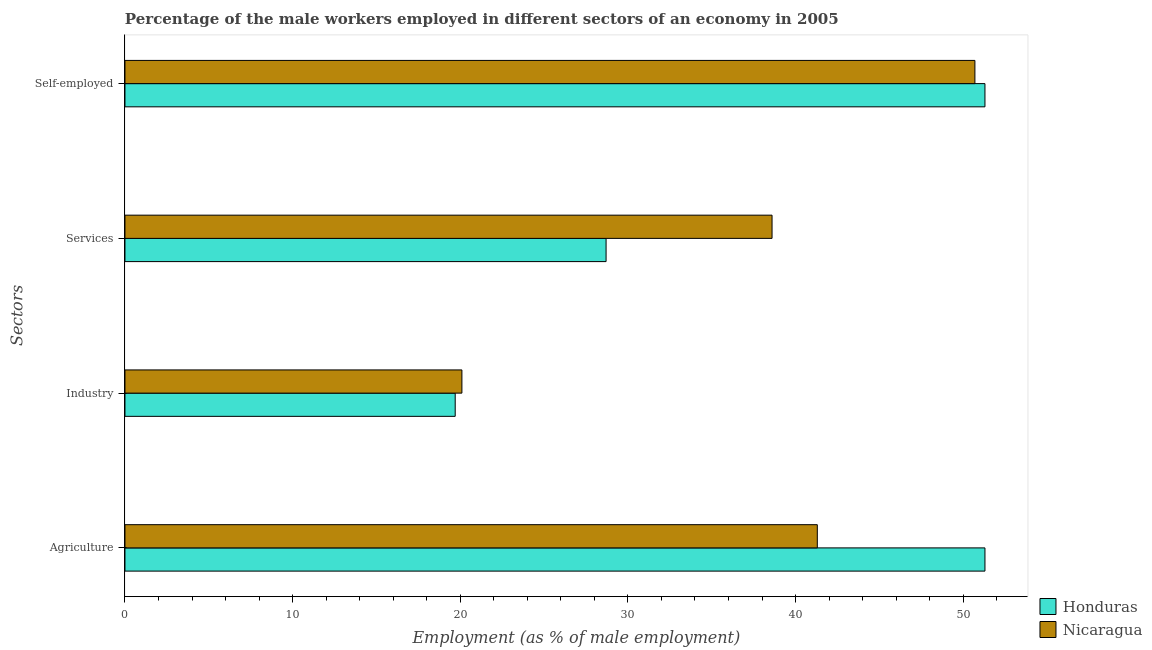How many groups of bars are there?
Make the answer very short. 4. Are the number of bars per tick equal to the number of legend labels?
Ensure brevity in your answer.  Yes. How many bars are there on the 2nd tick from the bottom?
Provide a succinct answer. 2. What is the label of the 3rd group of bars from the top?
Keep it short and to the point. Industry. What is the percentage of male workers in agriculture in Nicaragua?
Your response must be concise. 41.3. Across all countries, what is the maximum percentage of male workers in agriculture?
Ensure brevity in your answer.  51.3. Across all countries, what is the minimum percentage of self employed male workers?
Your answer should be compact. 50.7. In which country was the percentage of male workers in agriculture maximum?
Provide a succinct answer. Honduras. In which country was the percentage of male workers in agriculture minimum?
Ensure brevity in your answer.  Nicaragua. What is the total percentage of male workers in industry in the graph?
Your answer should be very brief. 39.8. What is the difference between the percentage of self employed male workers in Nicaragua and that in Honduras?
Provide a short and direct response. -0.6. What is the difference between the percentage of male workers in industry in Nicaragua and the percentage of self employed male workers in Honduras?
Your response must be concise. -31.2. What is the average percentage of male workers in agriculture per country?
Your answer should be very brief. 46.3. What is the difference between the percentage of male workers in services and percentage of self employed male workers in Nicaragua?
Your answer should be very brief. -12.1. What is the ratio of the percentage of male workers in industry in Nicaragua to that in Honduras?
Your answer should be compact. 1.02. What is the difference between the highest and the second highest percentage of male workers in services?
Ensure brevity in your answer.  9.9. What is the difference between the highest and the lowest percentage of self employed male workers?
Make the answer very short. 0.6. In how many countries, is the percentage of self employed male workers greater than the average percentage of self employed male workers taken over all countries?
Provide a succinct answer. 1. What does the 2nd bar from the top in Self-employed represents?
Offer a very short reply. Honduras. What does the 1st bar from the bottom in Self-employed represents?
Give a very brief answer. Honduras. Is it the case that in every country, the sum of the percentage of male workers in agriculture and percentage of male workers in industry is greater than the percentage of male workers in services?
Your response must be concise. Yes. How many countries are there in the graph?
Give a very brief answer. 2. What is the difference between two consecutive major ticks on the X-axis?
Your answer should be very brief. 10. Are the values on the major ticks of X-axis written in scientific E-notation?
Your answer should be compact. No. Where does the legend appear in the graph?
Offer a very short reply. Bottom right. How many legend labels are there?
Your answer should be compact. 2. How are the legend labels stacked?
Your answer should be very brief. Vertical. What is the title of the graph?
Provide a succinct answer. Percentage of the male workers employed in different sectors of an economy in 2005. What is the label or title of the X-axis?
Your response must be concise. Employment (as % of male employment). What is the label or title of the Y-axis?
Ensure brevity in your answer.  Sectors. What is the Employment (as % of male employment) in Honduras in Agriculture?
Your response must be concise. 51.3. What is the Employment (as % of male employment) in Nicaragua in Agriculture?
Your answer should be very brief. 41.3. What is the Employment (as % of male employment) of Honduras in Industry?
Provide a short and direct response. 19.7. What is the Employment (as % of male employment) in Nicaragua in Industry?
Give a very brief answer. 20.1. What is the Employment (as % of male employment) of Honduras in Services?
Ensure brevity in your answer.  28.7. What is the Employment (as % of male employment) in Nicaragua in Services?
Your answer should be very brief. 38.6. What is the Employment (as % of male employment) of Honduras in Self-employed?
Make the answer very short. 51.3. What is the Employment (as % of male employment) of Nicaragua in Self-employed?
Your answer should be very brief. 50.7. Across all Sectors, what is the maximum Employment (as % of male employment) in Honduras?
Offer a terse response. 51.3. Across all Sectors, what is the maximum Employment (as % of male employment) in Nicaragua?
Offer a very short reply. 50.7. Across all Sectors, what is the minimum Employment (as % of male employment) of Honduras?
Ensure brevity in your answer.  19.7. Across all Sectors, what is the minimum Employment (as % of male employment) of Nicaragua?
Provide a short and direct response. 20.1. What is the total Employment (as % of male employment) in Honduras in the graph?
Provide a succinct answer. 151. What is the total Employment (as % of male employment) in Nicaragua in the graph?
Provide a short and direct response. 150.7. What is the difference between the Employment (as % of male employment) of Honduras in Agriculture and that in Industry?
Your answer should be very brief. 31.6. What is the difference between the Employment (as % of male employment) in Nicaragua in Agriculture and that in Industry?
Your answer should be compact. 21.2. What is the difference between the Employment (as % of male employment) in Honduras in Agriculture and that in Services?
Your answer should be compact. 22.6. What is the difference between the Employment (as % of male employment) of Nicaragua in Agriculture and that in Services?
Ensure brevity in your answer.  2.7. What is the difference between the Employment (as % of male employment) of Honduras in Industry and that in Services?
Provide a short and direct response. -9. What is the difference between the Employment (as % of male employment) in Nicaragua in Industry and that in Services?
Your response must be concise. -18.5. What is the difference between the Employment (as % of male employment) of Honduras in Industry and that in Self-employed?
Keep it short and to the point. -31.6. What is the difference between the Employment (as % of male employment) of Nicaragua in Industry and that in Self-employed?
Your response must be concise. -30.6. What is the difference between the Employment (as % of male employment) of Honduras in Services and that in Self-employed?
Your answer should be very brief. -22.6. What is the difference between the Employment (as % of male employment) of Honduras in Agriculture and the Employment (as % of male employment) of Nicaragua in Industry?
Your response must be concise. 31.2. What is the difference between the Employment (as % of male employment) in Honduras in Agriculture and the Employment (as % of male employment) in Nicaragua in Self-employed?
Offer a very short reply. 0.6. What is the difference between the Employment (as % of male employment) in Honduras in Industry and the Employment (as % of male employment) in Nicaragua in Services?
Offer a very short reply. -18.9. What is the difference between the Employment (as % of male employment) of Honduras in Industry and the Employment (as % of male employment) of Nicaragua in Self-employed?
Ensure brevity in your answer.  -31. What is the difference between the Employment (as % of male employment) in Honduras in Services and the Employment (as % of male employment) in Nicaragua in Self-employed?
Provide a succinct answer. -22. What is the average Employment (as % of male employment) in Honduras per Sectors?
Offer a terse response. 37.75. What is the average Employment (as % of male employment) of Nicaragua per Sectors?
Give a very brief answer. 37.67. What is the ratio of the Employment (as % of male employment) of Honduras in Agriculture to that in Industry?
Your answer should be very brief. 2.6. What is the ratio of the Employment (as % of male employment) in Nicaragua in Agriculture to that in Industry?
Your response must be concise. 2.05. What is the ratio of the Employment (as % of male employment) in Honduras in Agriculture to that in Services?
Offer a terse response. 1.79. What is the ratio of the Employment (as % of male employment) of Nicaragua in Agriculture to that in Services?
Offer a terse response. 1.07. What is the ratio of the Employment (as % of male employment) in Honduras in Agriculture to that in Self-employed?
Your response must be concise. 1. What is the ratio of the Employment (as % of male employment) in Nicaragua in Agriculture to that in Self-employed?
Provide a succinct answer. 0.81. What is the ratio of the Employment (as % of male employment) in Honduras in Industry to that in Services?
Make the answer very short. 0.69. What is the ratio of the Employment (as % of male employment) in Nicaragua in Industry to that in Services?
Make the answer very short. 0.52. What is the ratio of the Employment (as % of male employment) of Honduras in Industry to that in Self-employed?
Your answer should be very brief. 0.38. What is the ratio of the Employment (as % of male employment) of Nicaragua in Industry to that in Self-employed?
Your answer should be compact. 0.4. What is the ratio of the Employment (as % of male employment) in Honduras in Services to that in Self-employed?
Keep it short and to the point. 0.56. What is the ratio of the Employment (as % of male employment) in Nicaragua in Services to that in Self-employed?
Your answer should be very brief. 0.76. What is the difference between the highest and the second highest Employment (as % of male employment) of Nicaragua?
Make the answer very short. 9.4. What is the difference between the highest and the lowest Employment (as % of male employment) in Honduras?
Make the answer very short. 31.6. What is the difference between the highest and the lowest Employment (as % of male employment) in Nicaragua?
Your answer should be compact. 30.6. 